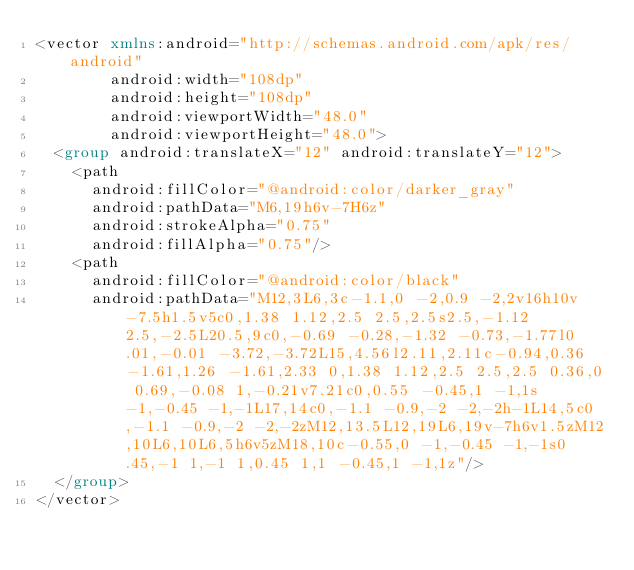<code> <loc_0><loc_0><loc_500><loc_500><_XML_><vector xmlns:android="http://schemas.android.com/apk/res/android"
        android:width="108dp"
        android:height="108dp"
        android:viewportWidth="48.0"
        android:viewportHeight="48.0">
  <group android:translateX="12" android:translateY="12">
    <path
      android:fillColor="@android:color/darker_gray"
      android:pathData="M6,19h6v-7H6z"
      android:strokeAlpha="0.75"
      android:fillAlpha="0.75"/>
    <path
      android:fillColor="@android:color/black"
      android:pathData="M12,3L6,3c-1.1,0 -2,0.9 -2,2v16h10v-7.5h1.5v5c0,1.38 1.12,2.5 2.5,2.5s2.5,-1.12 2.5,-2.5L20.5,9c0,-0.69 -0.28,-1.32 -0.73,-1.77l0.01,-0.01 -3.72,-3.72L15,4.56l2.11,2.11c-0.94,0.36 -1.61,1.26 -1.61,2.33 0,1.38 1.12,2.5 2.5,2.5 0.36,0 0.69,-0.08 1,-0.21v7.21c0,0.55 -0.45,1 -1,1s-1,-0.45 -1,-1L17,14c0,-1.1 -0.9,-2 -2,-2h-1L14,5c0,-1.1 -0.9,-2 -2,-2zM12,13.5L12,19L6,19v-7h6v1.5zM12,10L6,10L6,5h6v5zM18,10c-0.55,0 -1,-0.45 -1,-1s0.45,-1 1,-1 1,0.45 1,1 -0.45,1 -1,1z"/>
  </group>
</vector>
</code> 